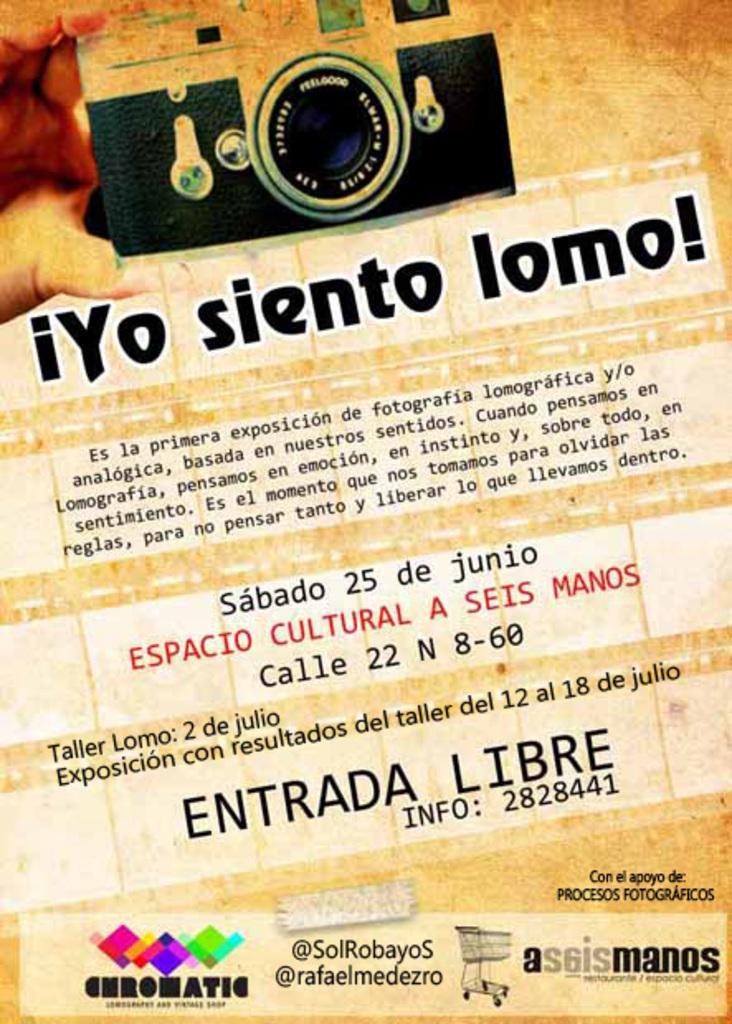How would you summarize this image in a sentence or two? In this image we can see a paper with the text. 